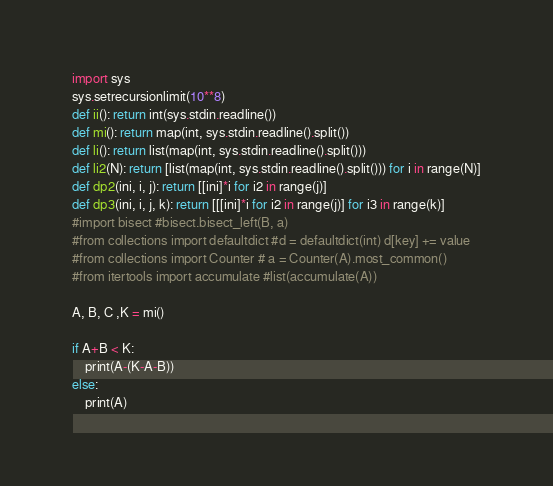<code> <loc_0><loc_0><loc_500><loc_500><_Python_>import sys
sys.setrecursionlimit(10**8)
def ii(): return int(sys.stdin.readline())
def mi(): return map(int, sys.stdin.readline().split())
def li(): return list(map(int, sys.stdin.readline().split()))
def li2(N): return [list(map(int, sys.stdin.readline().split())) for i in range(N)]
def dp2(ini, i, j): return [[ini]*i for i2 in range(j)]
def dp3(ini, i, j, k): return [[[ini]*i for i2 in range(j)] for i3 in range(k)]
#import bisect #bisect.bisect_left(B, a)
#from collections import defaultdict #d = defaultdict(int) d[key] += value
#from collections import Counter # a = Counter(A).most_common()
#from itertools import accumulate #list(accumulate(A))

A, B, C ,K = mi()

if A+B < K:
    print(A-(K-A-B))
else:
    print(A)</code> 